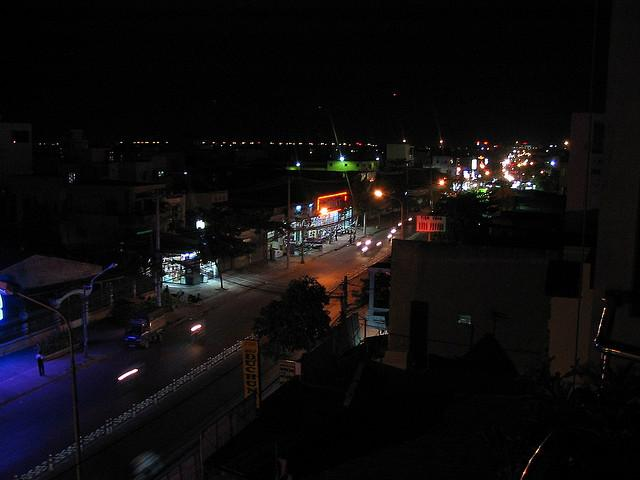What are is the image from? city 